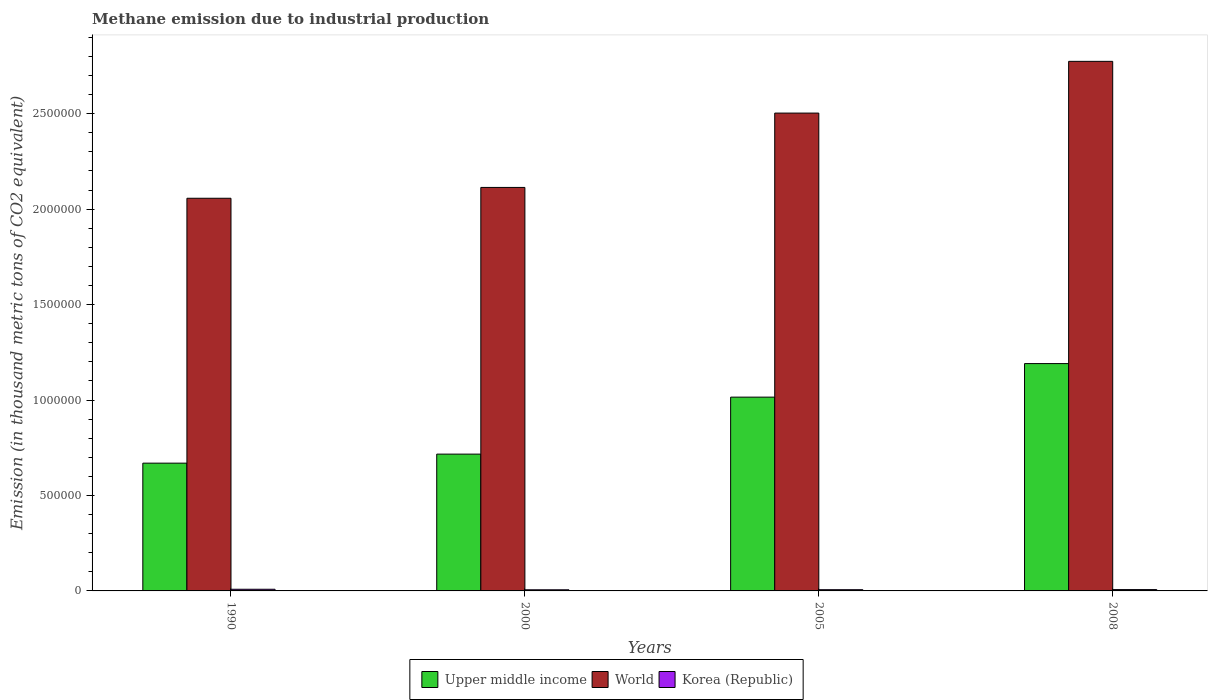How many bars are there on the 1st tick from the right?
Make the answer very short. 3. What is the amount of methane emitted in World in 2008?
Ensure brevity in your answer.  2.77e+06. Across all years, what is the maximum amount of methane emitted in Korea (Republic)?
Your answer should be very brief. 8754.2. Across all years, what is the minimum amount of methane emitted in Korea (Republic)?
Give a very brief answer. 5912.8. In which year was the amount of methane emitted in World minimum?
Ensure brevity in your answer.  1990. What is the total amount of methane emitted in Korea (Republic) in the graph?
Provide a short and direct response. 2.81e+04. What is the difference between the amount of methane emitted in World in 1990 and that in 2008?
Ensure brevity in your answer.  -7.17e+05. What is the difference between the amount of methane emitted in World in 2008 and the amount of methane emitted in Upper middle income in 2005?
Give a very brief answer. 1.76e+06. What is the average amount of methane emitted in Upper middle income per year?
Offer a terse response. 8.98e+05. In the year 2005, what is the difference between the amount of methane emitted in World and amount of methane emitted in Upper middle income?
Provide a short and direct response. 1.49e+06. What is the ratio of the amount of methane emitted in Upper middle income in 1990 to that in 2008?
Offer a very short reply. 0.56. Is the difference between the amount of methane emitted in World in 1990 and 2005 greater than the difference between the amount of methane emitted in Upper middle income in 1990 and 2005?
Ensure brevity in your answer.  No. What is the difference between the highest and the second highest amount of methane emitted in World?
Your answer should be compact. 2.71e+05. What is the difference between the highest and the lowest amount of methane emitted in World?
Your response must be concise. 7.17e+05. In how many years, is the amount of methane emitted in World greater than the average amount of methane emitted in World taken over all years?
Your answer should be very brief. 2. What does the 2nd bar from the left in 2000 represents?
Your response must be concise. World. How many years are there in the graph?
Ensure brevity in your answer.  4. What is the difference between two consecutive major ticks on the Y-axis?
Your answer should be very brief. 5.00e+05. Does the graph contain any zero values?
Offer a terse response. No. Does the graph contain grids?
Offer a terse response. No. How many legend labels are there?
Your response must be concise. 3. What is the title of the graph?
Keep it short and to the point. Methane emission due to industrial production. Does "Swaziland" appear as one of the legend labels in the graph?
Make the answer very short. No. What is the label or title of the X-axis?
Provide a succinct answer. Years. What is the label or title of the Y-axis?
Keep it short and to the point. Emission (in thousand metric tons of CO2 equivalent). What is the Emission (in thousand metric tons of CO2 equivalent) in Upper middle income in 1990?
Your response must be concise. 6.69e+05. What is the Emission (in thousand metric tons of CO2 equivalent) of World in 1990?
Offer a terse response. 2.06e+06. What is the Emission (in thousand metric tons of CO2 equivalent) in Korea (Republic) in 1990?
Your answer should be compact. 8754.2. What is the Emission (in thousand metric tons of CO2 equivalent) in Upper middle income in 2000?
Keep it short and to the point. 7.17e+05. What is the Emission (in thousand metric tons of CO2 equivalent) in World in 2000?
Your response must be concise. 2.11e+06. What is the Emission (in thousand metric tons of CO2 equivalent) in Korea (Republic) in 2000?
Make the answer very short. 5912.8. What is the Emission (in thousand metric tons of CO2 equivalent) in Upper middle income in 2005?
Offer a terse response. 1.02e+06. What is the Emission (in thousand metric tons of CO2 equivalent) of World in 2005?
Give a very brief answer. 2.50e+06. What is the Emission (in thousand metric tons of CO2 equivalent) in Korea (Republic) in 2005?
Your answer should be very brief. 6410.4. What is the Emission (in thousand metric tons of CO2 equivalent) in Upper middle income in 2008?
Provide a succinct answer. 1.19e+06. What is the Emission (in thousand metric tons of CO2 equivalent) in World in 2008?
Your response must be concise. 2.77e+06. What is the Emission (in thousand metric tons of CO2 equivalent) of Korea (Republic) in 2008?
Your answer should be compact. 6990.7. Across all years, what is the maximum Emission (in thousand metric tons of CO2 equivalent) in Upper middle income?
Offer a terse response. 1.19e+06. Across all years, what is the maximum Emission (in thousand metric tons of CO2 equivalent) in World?
Your answer should be very brief. 2.77e+06. Across all years, what is the maximum Emission (in thousand metric tons of CO2 equivalent) of Korea (Republic)?
Your answer should be very brief. 8754.2. Across all years, what is the minimum Emission (in thousand metric tons of CO2 equivalent) in Upper middle income?
Give a very brief answer. 6.69e+05. Across all years, what is the minimum Emission (in thousand metric tons of CO2 equivalent) in World?
Offer a terse response. 2.06e+06. Across all years, what is the minimum Emission (in thousand metric tons of CO2 equivalent) of Korea (Republic)?
Your answer should be compact. 5912.8. What is the total Emission (in thousand metric tons of CO2 equivalent) of Upper middle income in the graph?
Ensure brevity in your answer.  3.59e+06. What is the total Emission (in thousand metric tons of CO2 equivalent) of World in the graph?
Provide a short and direct response. 9.45e+06. What is the total Emission (in thousand metric tons of CO2 equivalent) in Korea (Republic) in the graph?
Your answer should be compact. 2.81e+04. What is the difference between the Emission (in thousand metric tons of CO2 equivalent) in Upper middle income in 1990 and that in 2000?
Provide a succinct answer. -4.72e+04. What is the difference between the Emission (in thousand metric tons of CO2 equivalent) in World in 1990 and that in 2000?
Give a very brief answer. -5.67e+04. What is the difference between the Emission (in thousand metric tons of CO2 equivalent) in Korea (Republic) in 1990 and that in 2000?
Offer a terse response. 2841.4. What is the difference between the Emission (in thousand metric tons of CO2 equivalent) of Upper middle income in 1990 and that in 2005?
Provide a short and direct response. -3.46e+05. What is the difference between the Emission (in thousand metric tons of CO2 equivalent) in World in 1990 and that in 2005?
Provide a succinct answer. -4.46e+05. What is the difference between the Emission (in thousand metric tons of CO2 equivalent) in Korea (Republic) in 1990 and that in 2005?
Keep it short and to the point. 2343.8. What is the difference between the Emission (in thousand metric tons of CO2 equivalent) of Upper middle income in 1990 and that in 2008?
Offer a terse response. -5.22e+05. What is the difference between the Emission (in thousand metric tons of CO2 equivalent) of World in 1990 and that in 2008?
Provide a short and direct response. -7.17e+05. What is the difference between the Emission (in thousand metric tons of CO2 equivalent) of Korea (Republic) in 1990 and that in 2008?
Your response must be concise. 1763.5. What is the difference between the Emission (in thousand metric tons of CO2 equivalent) of Upper middle income in 2000 and that in 2005?
Provide a short and direct response. -2.99e+05. What is the difference between the Emission (in thousand metric tons of CO2 equivalent) of World in 2000 and that in 2005?
Offer a very short reply. -3.90e+05. What is the difference between the Emission (in thousand metric tons of CO2 equivalent) of Korea (Republic) in 2000 and that in 2005?
Your response must be concise. -497.6. What is the difference between the Emission (in thousand metric tons of CO2 equivalent) in Upper middle income in 2000 and that in 2008?
Provide a short and direct response. -4.74e+05. What is the difference between the Emission (in thousand metric tons of CO2 equivalent) in World in 2000 and that in 2008?
Your answer should be compact. -6.61e+05. What is the difference between the Emission (in thousand metric tons of CO2 equivalent) in Korea (Republic) in 2000 and that in 2008?
Provide a succinct answer. -1077.9. What is the difference between the Emission (in thousand metric tons of CO2 equivalent) in Upper middle income in 2005 and that in 2008?
Provide a succinct answer. -1.76e+05. What is the difference between the Emission (in thousand metric tons of CO2 equivalent) in World in 2005 and that in 2008?
Your answer should be compact. -2.71e+05. What is the difference between the Emission (in thousand metric tons of CO2 equivalent) in Korea (Republic) in 2005 and that in 2008?
Your answer should be compact. -580.3. What is the difference between the Emission (in thousand metric tons of CO2 equivalent) in Upper middle income in 1990 and the Emission (in thousand metric tons of CO2 equivalent) in World in 2000?
Provide a short and direct response. -1.44e+06. What is the difference between the Emission (in thousand metric tons of CO2 equivalent) in Upper middle income in 1990 and the Emission (in thousand metric tons of CO2 equivalent) in Korea (Republic) in 2000?
Offer a very short reply. 6.64e+05. What is the difference between the Emission (in thousand metric tons of CO2 equivalent) in World in 1990 and the Emission (in thousand metric tons of CO2 equivalent) in Korea (Republic) in 2000?
Your answer should be very brief. 2.05e+06. What is the difference between the Emission (in thousand metric tons of CO2 equivalent) in Upper middle income in 1990 and the Emission (in thousand metric tons of CO2 equivalent) in World in 2005?
Give a very brief answer. -1.83e+06. What is the difference between the Emission (in thousand metric tons of CO2 equivalent) of Upper middle income in 1990 and the Emission (in thousand metric tons of CO2 equivalent) of Korea (Republic) in 2005?
Your answer should be very brief. 6.63e+05. What is the difference between the Emission (in thousand metric tons of CO2 equivalent) of World in 1990 and the Emission (in thousand metric tons of CO2 equivalent) of Korea (Republic) in 2005?
Offer a very short reply. 2.05e+06. What is the difference between the Emission (in thousand metric tons of CO2 equivalent) in Upper middle income in 1990 and the Emission (in thousand metric tons of CO2 equivalent) in World in 2008?
Keep it short and to the point. -2.10e+06. What is the difference between the Emission (in thousand metric tons of CO2 equivalent) of Upper middle income in 1990 and the Emission (in thousand metric tons of CO2 equivalent) of Korea (Republic) in 2008?
Keep it short and to the point. 6.62e+05. What is the difference between the Emission (in thousand metric tons of CO2 equivalent) of World in 1990 and the Emission (in thousand metric tons of CO2 equivalent) of Korea (Republic) in 2008?
Offer a very short reply. 2.05e+06. What is the difference between the Emission (in thousand metric tons of CO2 equivalent) of Upper middle income in 2000 and the Emission (in thousand metric tons of CO2 equivalent) of World in 2005?
Offer a very short reply. -1.79e+06. What is the difference between the Emission (in thousand metric tons of CO2 equivalent) of Upper middle income in 2000 and the Emission (in thousand metric tons of CO2 equivalent) of Korea (Republic) in 2005?
Make the answer very short. 7.10e+05. What is the difference between the Emission (in thousand metric tons of CO2 equivalent) in World in 2000 and the Emission (in thousand metric tons of CO2 equivalent) in Korea (Republic) in 2005?
Offer a very short reply. 2.11e+06. What is the difference between the Emission (in thousand metric tons of CO2 equivalent) of Upper middle income in 2000 and the Emission (in thousand metric tons of CO2 equivalent) of World in 2008?
Ensure brevity in your answer.  -2.06e+06. What is the difference between the Emission (in thousand metric tons of CO2 equivalent) in Upper middle income in 2000 and the Emission (in thousand metric tons of CO2 equivalent) in Korea (Republic) in 2008?
Provide a short and direct response. 7.10e+05. What is the difference between the Emission (in thousand metric tons of CO2 equivalent) in World in 2000 and the Emission (in thousand metric tons of CO2 equivalent) in Korea (Republic) in 2008?
Provide a succinct answer. 2.11e+06. What is the difference between the Emission (in thousand metric tons of CO2 equivalent) of Upper middle income in 2005 and the Emission (in thousand metric tons of CO2 equivalent) of World in 2008?
Your answer should be very brief. -1.76e+06. What is the difference between the Emission (in thousand metric tons of CO2 equivalent) in Upper middle income in 2005 and the Emission (in thousand metric tons of CO2 equivalent) in Korea (Republic) in 2008?
Your answer should be compact. 1.01e+06. What is the difference between the Emission (in thousand metric tons of CO2 equivalent) of World in 2005 and the Emission (in thousand metric tons of CO2 equivalent) of Korea (Republic) in 2008?
Keep it short and to the point. 2.50e+06. What is the average Emission (in thousand metric tons of CO2 equivalent) in Upper middle income per year?
Your answer should be compact. 8.98e+05. What is the average Emission (in thousand metric tons of CO2 equivalent) in World per year?
Your answer should be very brief. 2.36e+06. What is the average Emission (in thousand metric tons of CO2 equivalent) in Korea (Republic) per year?
Provide a succinct answer. 7017.02. In the year 1990, what is the difference between the Emission (in thousand metric tons of CO2 equivalent) in Upper middle income and Emission (in thousand metric tons of CO2 equivalent) in World?
Provide a short and direct response. -1.39e+06. In the year 1990, what is the difference between the Emission (in thousand metric tons of CO2 equivalent) in Upper middle income and Emission (in thousand metric tons of CO2 equivalent) in Korea (Republic)?
Provide a succinct answer. 6.61e+05. In the year 1990, what is the difference between the Emission (in thousand metric tons of CO2 equivalent) of World and Emission (in thousand metric tons of CO2 equivalent) of Korea (Republic)?
Make the answer very short. 2.05e+06. In the year 2000, what is the difference between the Emission (in thousand metric tons of CO2 equivalent) in Upper middle income and Emission (in thousand metric tons of CO2 equivalent) in World?
Give a very brief answer. -1.40e+06. In the year 2000, what is the difference between the Emission (in thousand metric tons of CO2 equivalent) in Upper middle income and Emission (in thousand metric tons of CO2 equivalent) in Korea (Republic)?
Make the answer very short. 7.11e+05. In the year 2000, what is the difference between the Emission (in thousand metric tons of CO2 equivalent) in World and Emission (in thousand metric tons of CO2 equivalent) in Korea (Republic)?
Offer a very short reply. 2.11e+06. In the year 2005, what is the difference between the Emission (in thousand metric tons of CO2 equivalent) of Upper middle income and Emission (in thousand metric tons of CO2 equivalent) of World?
Your response must be concise. -1.49e+06. In the year 2005, what is the difference between the Emission (in thousand metric tons of CO2 equivalent) of Upper middle income and Emission (in thousand metric tons of CO2 equivalent) of Korea (Republic)?
Offer a very short reply. 1.01e+06. In the year 2005, what is the difference between the Emission (in thousand metric tons of CO2 equivalent) of World and Emission (in thousand metric tons of CO2 equivalent) of Korea (Republic)?
Offer a very short reply. 2.50e+06. In the year 2008, what is the difference between the Emission (in thousand metric tons of CO2 equivalent) of Upper middle income and Emission (in thousand metric tons of CO2 equivalent) of World?
Give a very brief answer. -1.58e+06. In the year 2008, what is the difference between the Emission (in thousand metric tons of CO2 equivalent) in Upper middle income and Emission (in thousand metric tons of CO2 equivalent) in Korea (Republic)?
Your answer should be compact. 1.18e+06. In the year 2008, what is the difference between the Emission (in thousand metric tons of CO2 equivalent) in World and Emission (in thousand metric tons of CO2 equivalent) in Korea (Republic)?
Ensure brevity in your answer.  2.77e+06. What is the ratio of the Emission (in thousand metric tons of CO2 equivalent) in Upper middle income in 1990 to that in 2000?
Your response must be concise. 0.93. What is the ratio of the Emission (in thousand metric tons of CO2 equivalent) of World in 1990 to that in 2000?
Give a very brief answer. 0.97. What is the ratio of the Emission (in thousand metric tons of CO2 equivalent) in Korea (Republic) in 1990 to that in 2000?
Your answer should be very brief. 1.48. What is the ratio of the Emission (in thousand metric tons of CO2 equivalent) in Upper middle income in 1990 to that in 2005?
Give a very brief answer. 0.66. What is the ratio of the Emission (in thousand metric tons of CO2 equivalent) in World in 1990 to that in 2005?
Make the answer very short. 0.82. What is the ratio of the Emission (in thousand metric tons of CO2 equivalent) in Korea (Republic) in 1990 to that in 2005?
Keep it short and to the point. 1.37. What is the ratio of the Emission (in thousand metric tons of CO2 equivalent) in Upper middle income in 1990 to that in 2008?
Keep it short and to the point. 0.56. What is the ratio of the Emission (in thousand metric tons of CO2 equivalent) of World in 1990 to that in 2008?
Provide a short and direct response. 0.74. What is the ratio of the Emission (in thousand metric tons of CO2 equivalent) in Korea (Republic) in 1990 to that in 2008?
Your answer should be very brief. 1.25. What is the ratio of the Emission (in thousand metric tons of CO2 equivalent) in Upper middle income in 2000 to that in 2005?
Your response must be concise. 0.71. What is the ratio of the Emission (in thousand metric tons of CO2 equivalent) in World in 2000 to that in 2005?
Your answer should be compact. 0.84. What is the ratio of the Emission (in thousand metric tons of CO2 equivalent) in Korea (Republic) in 2000 to that in 2005?
Keep it short and to the point. 0.92. What is the ratio of the Emission (in thousand metric tons of CO2 equivalent) in Upper middle income in 2000 to that in 2008?
Your answer should be very brief. 0.6. What is the ratio of the Emission (in thousand metric tons of CO2 equivalent) of World in 2000 to that in 2008?
Your answer should be very brief. 0.76. What is the ratio of the Emission (in thousand metric tons of CO2 equivalent) of Korea (Republic) in 2000 to that in 2008?
Give a very brief answer. 0.85. What is the ratio of the Emission (in thousand metric tons of CO2 equivalent) in Upper middle income in 2005 to that in 2008?
Your answer should be very brief. 0.85. What is the ratio of the Emission (in thousand metric tons of CO2 equivalent) in World in 2005 to that in 2008?
Offer a terse response. 0.9. What is the ratio of the Emission (in thousand metric tons of CO2 equivalent) in Korea (Republic) in 2005 to that in 2008?
Offer a very short reply. 0.92. What is the difference between the highest and the second highest Emission (in thousand metric tons of CO2 equivalent) in Upper middle income?
Your answer should be very brief. 1.76e+05. What is the difference between the highest and the second highest Emission (in thousand metric tons of CO2 equivalent) of World?
Ensure brevity in your answer.  2.71e+05. What is the difference between the highest and the second highest Emission (in thousand metric tons of CO2 equivalent) in Korea (Republic)?
Provide a short and direct response. 1763.5. What is the difference between the highest and the lowest Emission (in thousand metric tons of CO2 equivalent) in Upper middle income?
Your answer should be compact. 5.22e+05. What is the difference between the highest and the lowest Emission (in thousand metric tons of CO2 equivalent) of World?
Offer a terse response. 7.17e+05. What is the difference between the highest and the lowest Emission (in thousand metric tons of CO2 equivalent) of Korea (Republic)?
Your answer should be compact. 2841.4. 